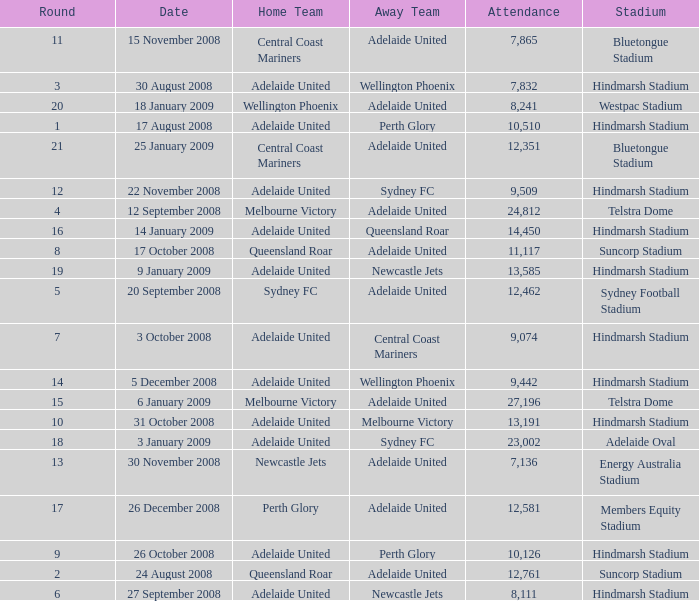Parse the table in full. {'header': ['Round', 'Date', 'Home Team', 'Away Team', 'Attendance', 'Stadium'], 'rows': [['11', '15 November 2008', 'Central Coast Mariners', 'Adelaide United', '7,865', 'Bluetongue Stadium'], ['3', '30 August 2008', 'Adelaide United', 'Wellington Phoenix', '7,832', 'Hindmarsh Stadium'], ['20', '18 January 2009', 'Wellington Phoenix', 'Adelaide United', '8,241', 'Westpac Stadium'], ['1', '17 August 2008', 'Adelaide United', 'Perth Glory', '10,510', 'Hindmarsh Stadium'], ['21', '25 January 2009', 'Central Coast Mariners', 'Adelaide United', '12,351', 'Bluetongue Stadium'], ['12', '22 November 2008', 'Adelaide United', 'Sydney FC', '9,509', 'Hindmarsh Stadium'], ['4', '12 September 2008', 'Melbourne Victory', 'Adelaide United', '24,812', 'Telstra Dome'], ['16', '14 January 2009', 'Adelaide United', 'Queensland Roar', '14,450', 'Hindmarsh Stadium'], ['8', '17 October 2008', 'Queensland Roar', 'Adelaide United', '11,117', 'Suncorp Stadium'], ['19', '9 January 2009', 'Adelaide United', 'Newcastle Jets', '13,585', 'Hindmarsh Stadium'], ['5', '20 September 2008', 'Sydney FC', 'Adelaide United', '12,462', 'Sydney Football Stadium'], ['7', '3 October 2008', 'Adelaide United', 'Central Coast Mariners', '9,074', 'Hindmarsh Stadium'], ['14', '5 December 2008', 'Adelaide United', 'Wellington Phoenix', '9,442', 'Hindmarsh Stadium'], ['15', '6 January 2009', 'Melbourne Victory', 'Adelaide United', '27,196', 'Telstra Dome'], ['10', '31 October 2008', 'Adelaide United', 'Melbourne Victory', '13,191', 'Hindmarsh Stadium'], ['18', '3 January 2009', 'Adelaide United', 'Sydney FC', '23,002', 'Adelaide Oval'], ['13', '30 November 2008', 'Newcastle Jets', 'Adelaide United', '7,136', 'Energy Australia Stadium'], ['17', '26 December 2008', 'Perth Glory', 'Adelaide United', '12,581', 'Members Equity Stadium'], ['9', '26 October 2008', 'Adelaide United', 'Perth Glory', '10,126', 'Hindmarsh Stadium'], ['2', '24 August 2008', 'Queensland Roar', 'Adelaide United', '12,761', 'Suncorp Stadium'], ['6', '27 September 2008', 'Adelaide United', 'Newcastle Jets', '8,111', 'Hindmarsh Stadium']]} What is the circular when 11,117 individuals were present at the match on 26 october 2008? 9.0. 